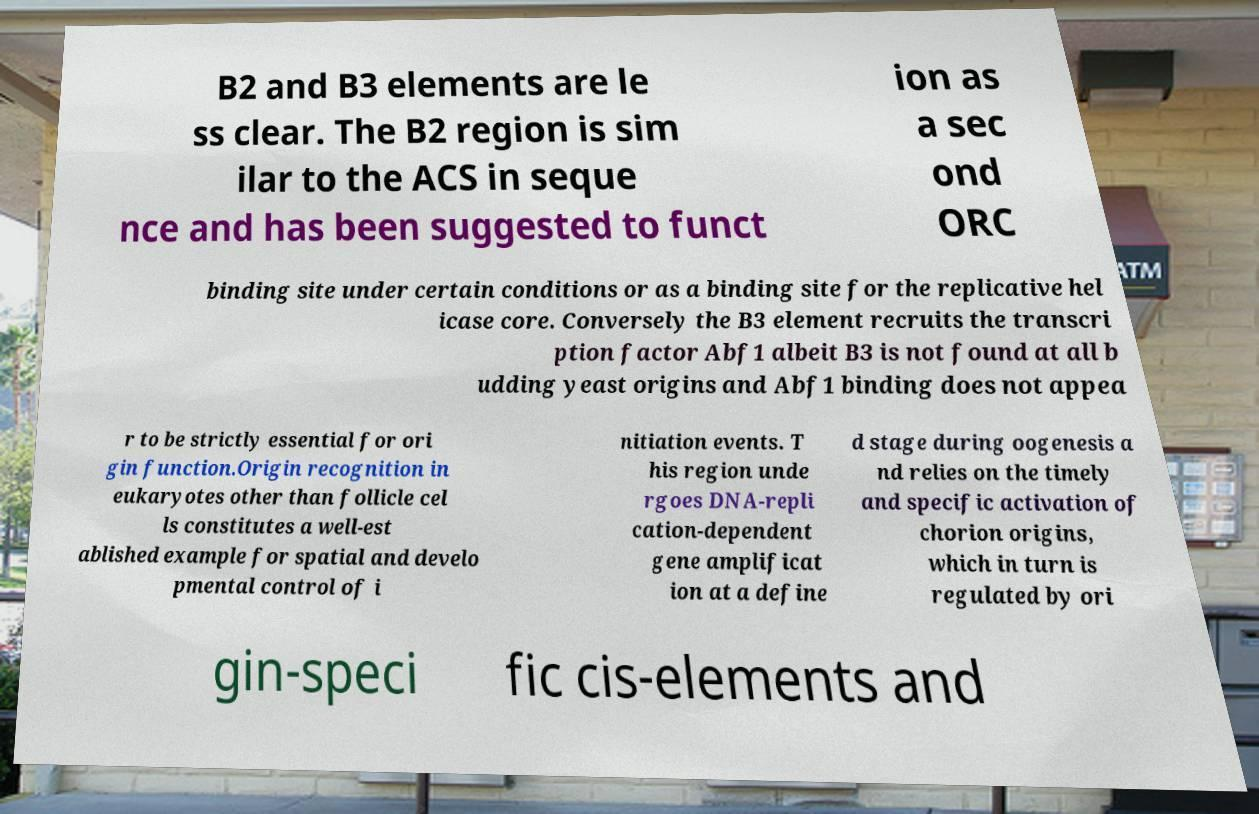Please identify and transcribe the text found in this image. B2 and B3 elements are le ss clear. The B2 region is sim ilar to the ACS in seque nce and has been suggested to funct ion as a sec ond ORC binding site under certain conditions or as a binding site for the replicative hel icase core. Conversely the B3 element recruits the transcri ption factor Abf1 albeit B3 is not found at all b udding yeast origins and Abf1 binding does not appea r to be strictly essential for ori gin function.Origin recognition in eukaryotes other than follicle cel ls constitutes a well-est ablished example for spatial and develo pmental control of i nitiation events. T his region unde rgoes DNA-repli cation-dependent gene amplificat ion at a define d stage during oogenesis a nd relies on the timely and specific activation of chorion origins, which in turn is regulated by ori gin-speci fic cis-elements and 